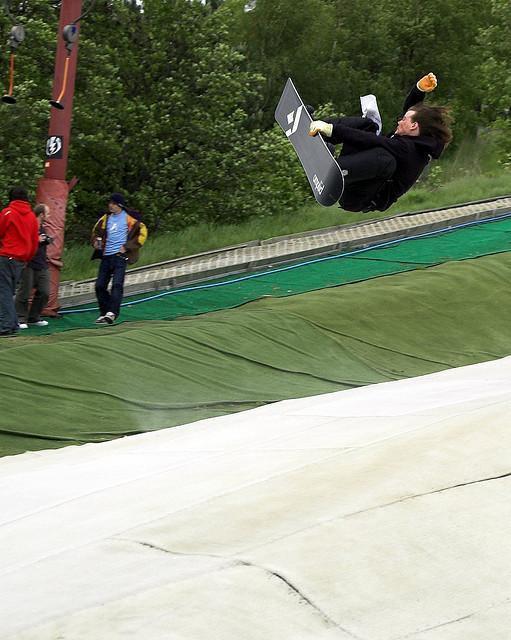What type of board is this?
Choose the correct response and explain in the format: 'Answer: answer
Rationale: rationale.'
Options: Topple board, skate board, snow board, balance board. Answer: skate board.
Rationale: Is the most likely answer given the background skate area and time of year. 